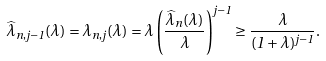Convert formula to latex. <formula><loc_0><loc_0><loc_500><loc_500>\widehat { \lambda } _ { n , j - 1 } ( \lambda ) = \lambda _ { n , j } ( \lambda ) = \lambda \left ( \frac { \widehat { \lambda } _ { n } ( \lambda ) } { \lambda } \right ) ^ { j - 1 } \geq \frac { \lambda } { ( 1 + \lambda ) ^ { j - 1 } } .</formula> 